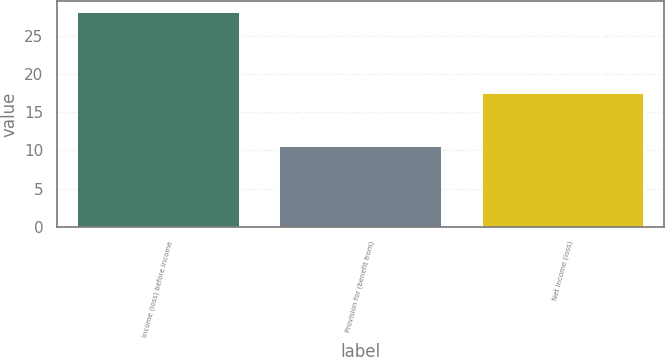<chart> <loc_0><loc_0><loc_500><loc_500><bar_chart><fcel>Income (loss) before income<fcel>Provision for (benefit from)<fcel>Net income (loss)<nl><fcel>28.1<fcel>10.6<fcel>17.5<nl></chart> 